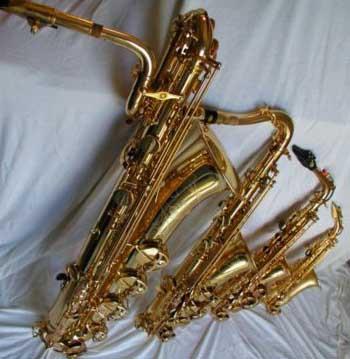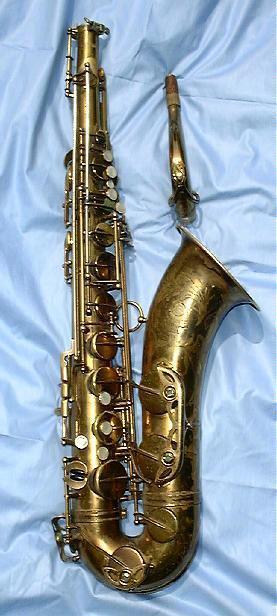The first image is the image on the left, the second image is the image on the right. Examine the images to the left and right. Is the description "There are only two saxophones." accurate? Answer yes or no. No. 